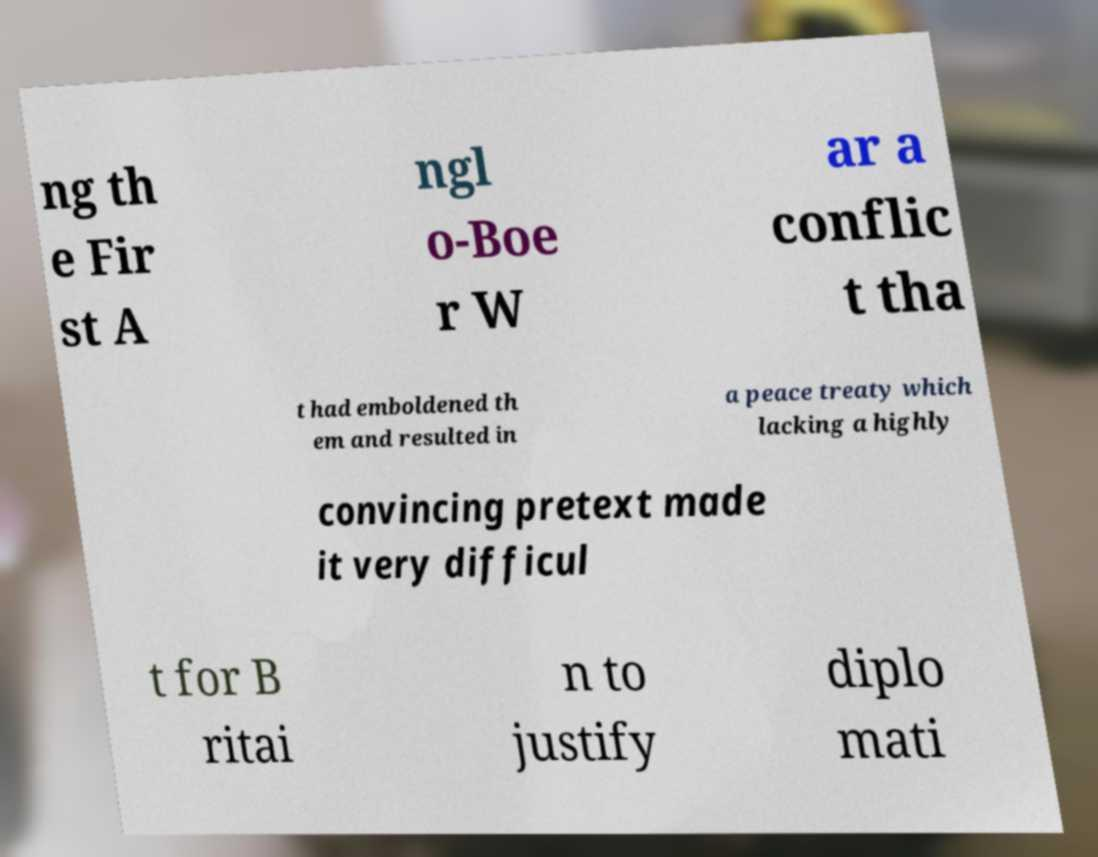Could you extract and type out the text from this image? ng th e Fir st A ngl o-Boe r W ar a conflic t tha t had emboldened th em and resulted in a peace treaty which lacking a highly convincing pretext made it very difficul t for B ritai n to justify diplo mati 